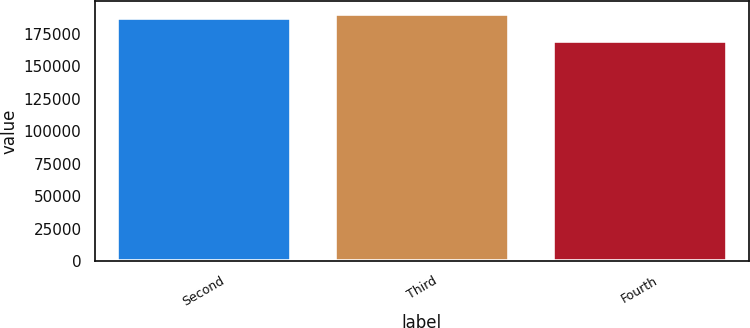<chart> <loc_0><loc_0><loc_500><loc_500><bar_chart><fcel>Second<fcel>Third<fcel>Fourth<nl><fcel>186911<fcel>190335<fcel>169582<nl></chart> 